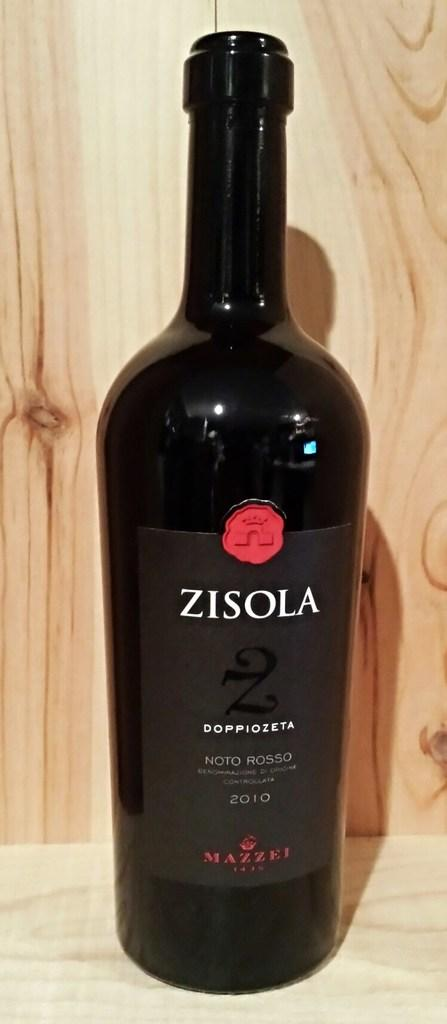Provide a one-sentence caption for the provided image. A black bottle of wine with red and white lettering. 